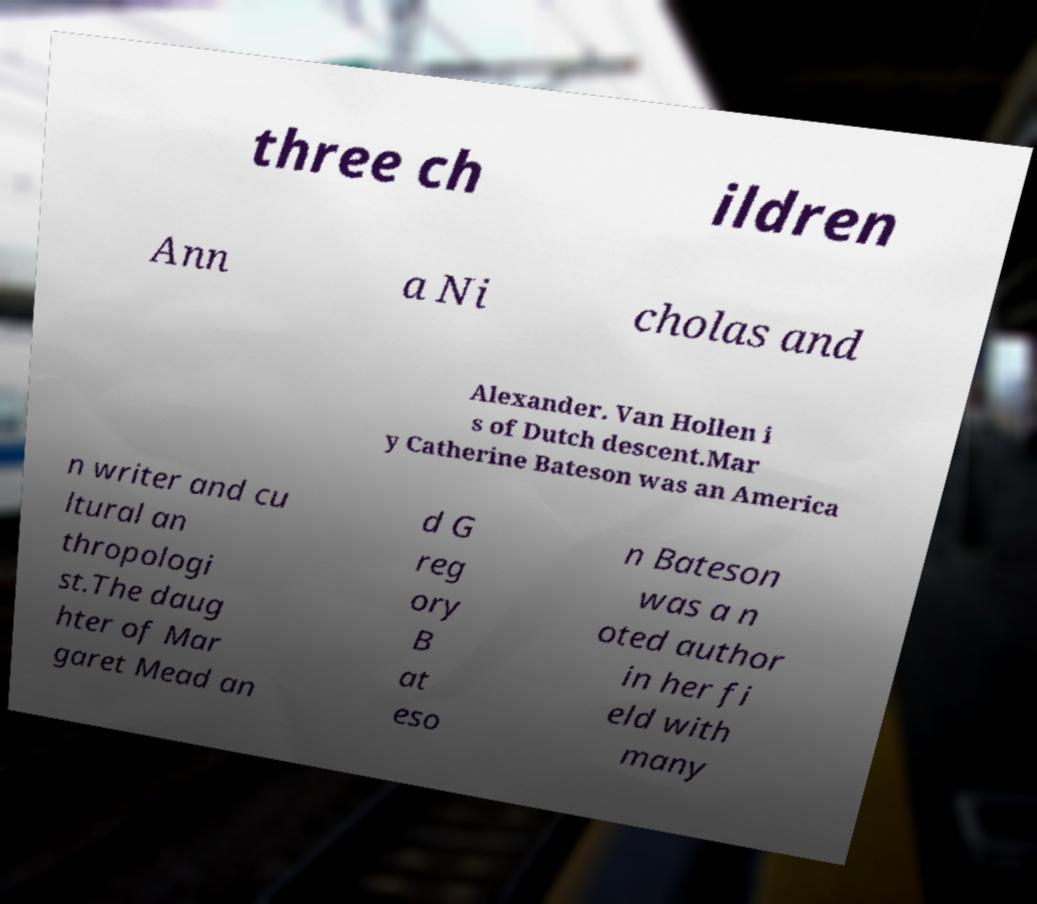There's text embedded in this image that I need extracted. Can you transcribe it verbatim? three ch ildren Ann a Ni cholas and Alexander. Van Hollen i s of Dutch descent.Mar y Catherine Bateson was an America n writer and cu ltural an thropologi st.The daug hter of Mar garet Mead an d G reg ory B at eso n Bateson was a n oted author in her fi eld with many 